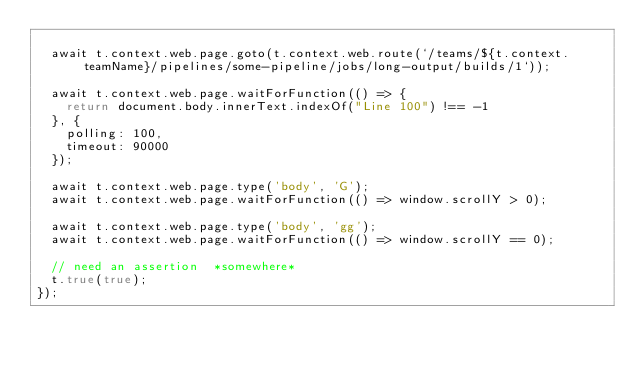<code> <loc_0><loc_0><loc_500><loc_500><_JavaScript_>
  await t.context.web.page.goto(t.context.web.route(`/teams/${t.context.teamName}/pipelines/some-pipeline/jobs/long-output/builds/1`));

  await t.context.web.page.waitForFunction(() => {
    return document.body.innerText.indexOf("Line 100") !== -1
  }, {
    polling: 100,
    timeout: 90000
  });

  await t.context.web.page.type('body', 'G');
  await t.context.web.page.waitForFunction(() => window.scrollY > 0);

  await t.context.web.page.type('body', 'gg');
  await t.context.web.page.waitForFunction(() => window.scrollY == 0);

  // need an assertion  *somewhere*
  t.true(true);
});
</code> 